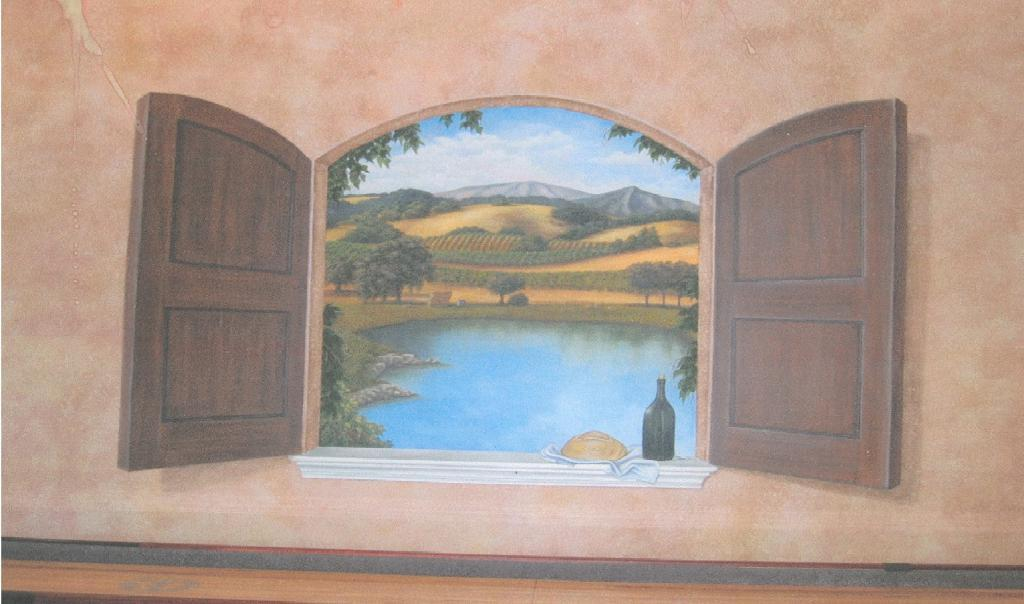What is the main subject of the image? There is a painting in the image. What can be seen in the background of the painting? There is a window, water, trees, mountains, and the sky visible in the image. Can you describe the setting of the painting? The painting features a window with a view of water, trees, mountains, and the sky. What type of humor can be seen in the painting? There is no humor depicted in the painting; it is a landscape featuring a window, water, trees, mountains, and the sky. What color is the ear in the painting? There is no ear present in the painting; it is a landscape featuring a window, water, trees, mountains, and the sky. 